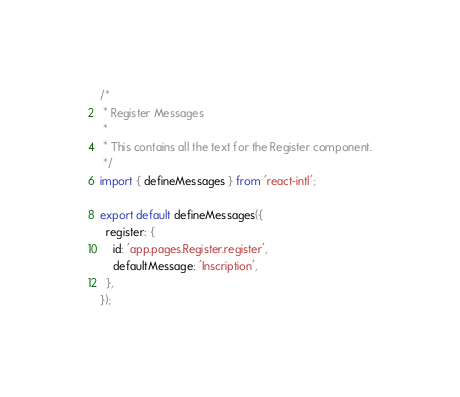<code> <loc_0><loc_0><loc_500><loc_500><_JavaScript_>/*
 * Register Messages
 *
 * This contains all the text for the Register component.
 */
import { defineMessages } from 'react-intl';

export default defineMessages({
  register: {
    id: 'app.pages.Register.register',
    defaultMessage: 'Inscription',
  },
});
</code> 